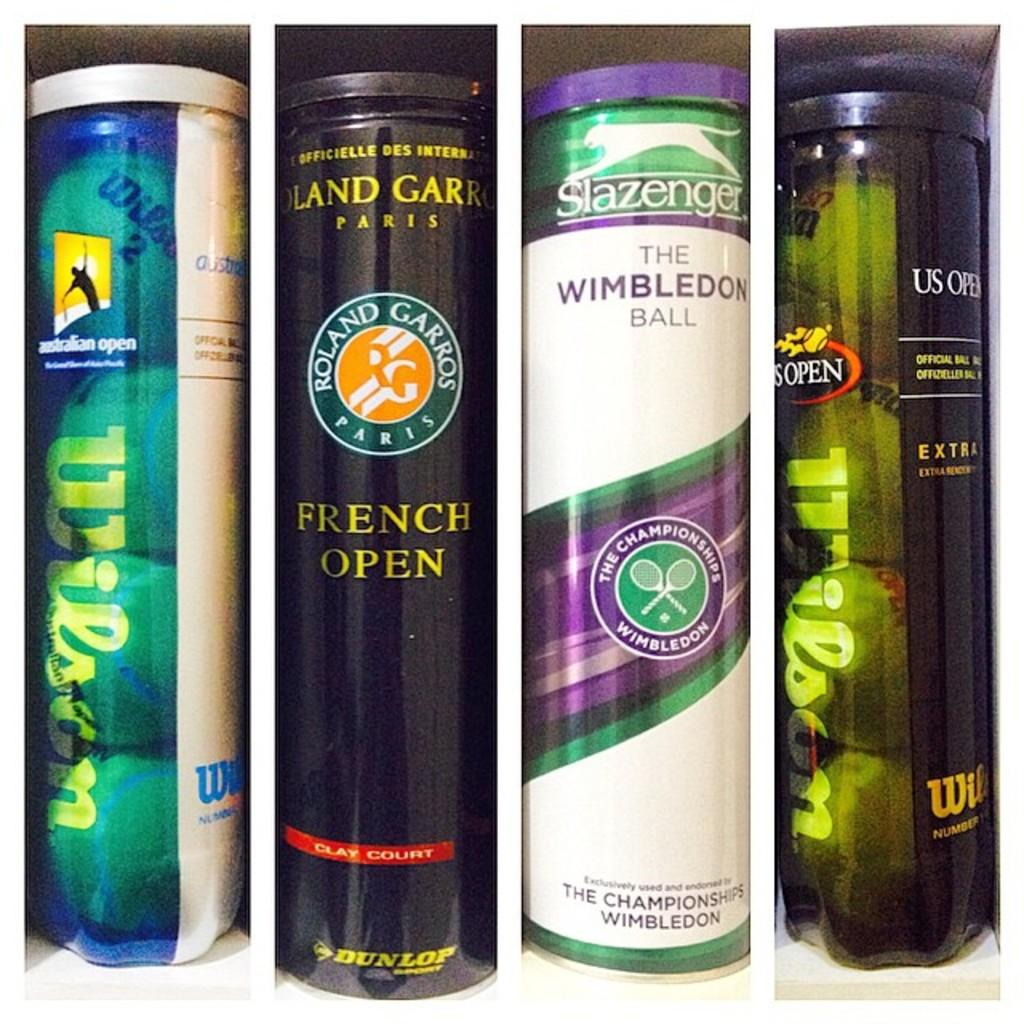<image>
Provide a brief description of the given image. Several cans of tennis balls are next to each other, some are from the French Open. 